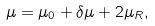<formula> <loc_0><loc_0><loc_500><loc_500>\mu = \mu _ { 0 } + \delta \mu + 2 \mu _ { R } ,</formula> 